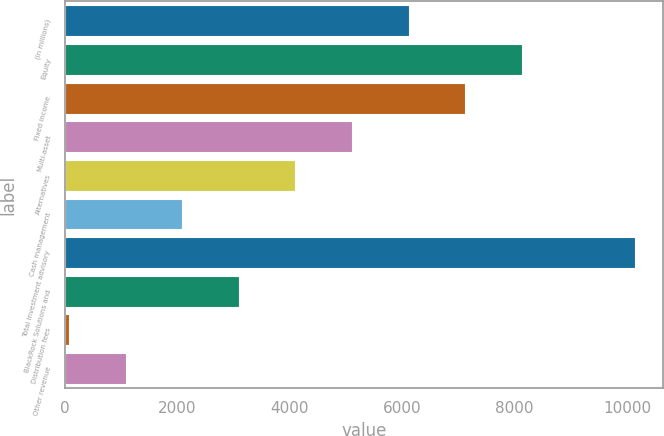Convert chart. <chart><loc_0><loc_0><loc_500><loc_500><bar_chart><fcel>(in millions)<fcel>Equity<fcel>Fixed income<fcel>Multi-asset<fcel>Alternatives<fcel>Cash management<fcel>Total investment advisory<fcel>BlackRock Solutions and<fcel>Distribution fees<fcel>Other revenue<nl><fcel>6111.4<fcel>8125.2<fcel>7118.3<fcel>5104.5<fcel>4097.6<fcel>2083.8<fcel>10139<fcel>3090.7<fcel>70<fcel>1076.9<nl></chart> 